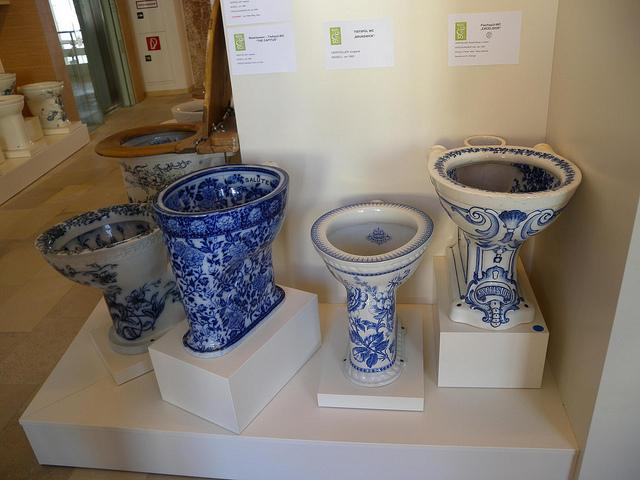Where would this style of porcelain item be found in a house? Please explain your reasoning. bathroom. Usually toilets are in the bathroom. 